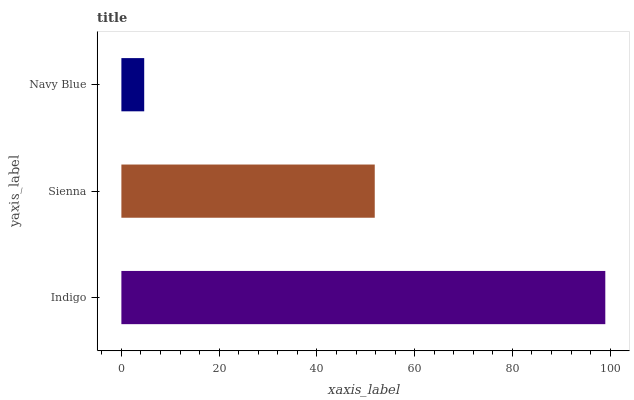Is Navy Blue the minimum?
Answer yes or no. Yes. Is Indigo the maximum?
Answer yes or no. Yes. Is Sienna the minimum?
Answer yes or no. No. Is Sienna the maximum?
Answer yes or no. No. Is Indigo greater than Sienna?
Answer yes or no. Yes. Is Sienna less than Indigo?
Answer yes or no. Yes. Is Sienna greater than Indigo?
Answer yes or no. No. Is Indigo less than Sienna?
Answer yes or no. No. Is Sienna the high median?
Answer yes or no. Yes. Is Sienna the low median?
Answer yes or no. Yes. Is Navy Blue the high median?
Answer yes or no. No. Is Navy Blue the low median?
Answer yes or no. No. 